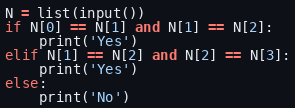<code> <loc_0><loc_0><loc_500><loc_500><_Python_>N = list(input())
if N[0] == N[1] and N[1] == N[2]:
    print('Yes')
elif N[1] == N[2] and N[2] == N[3]:
    print('Yes')
else:
    print('No')</code> 